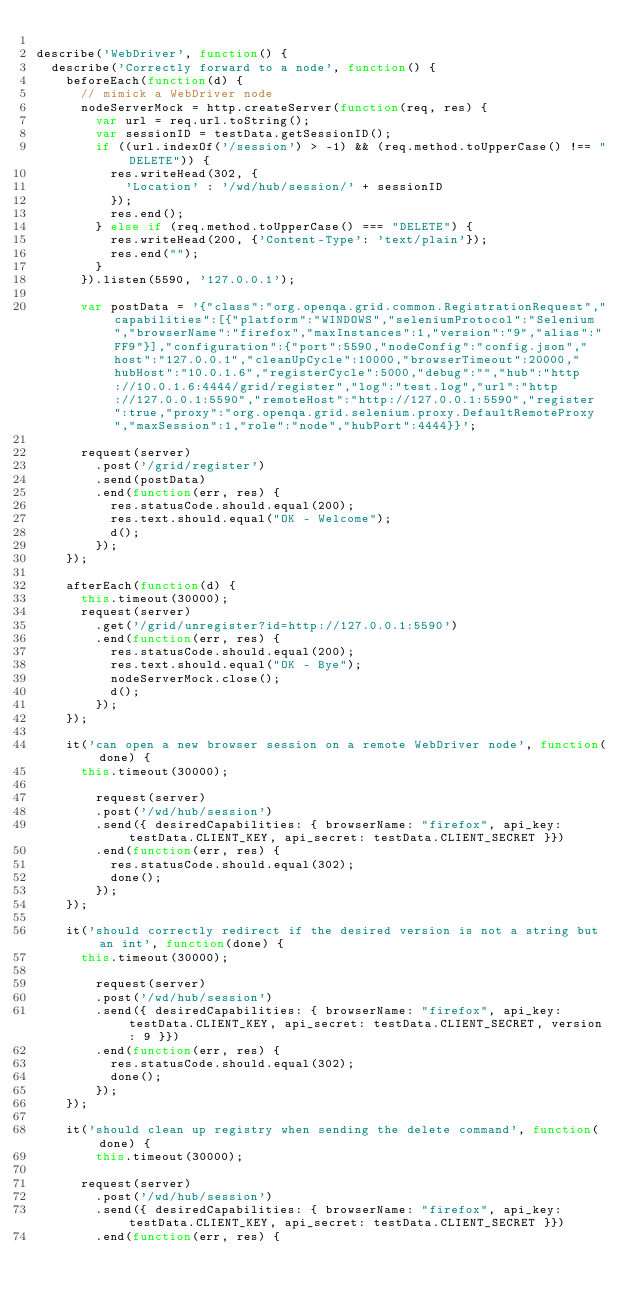<code> <loc_0><loc_0><loc_500><loc_500><_JavaScript_>
describe('WebDriver', function() {
	describe('Correctly forward to a node', function() {
		beforeEach(function(d) {
			// mimick a WebDriver node
			nodeServerMock = http.createServer(function(req, res) {
			  var url = req.url.toString();
			  var sessionID = testData.getSessionID();
			  if ((url.indexOf('/session') > -1) && (req.method.toUpperCase() !== "DELETE")) {
			  	res.writeHead(302, {
			  		'Location' : '/wd/hub/session/' + sessionID
			  	});
			  	res.end();
			  } else if (req.method.toUpperCase() === "DELETE") {
			  	res.writeHead(200, {'Content-Type': 'text/plain'});
	  			res.end("");
			  }
			}).listen(5590, '127.0.0.1');

			var postData = '{"class":"org.openqa.grid.common.RegistrationRequest","capabilities":[{"platform":"WINDOWS","seleniumProtocol":"Selenium","browserName":"firefox","maxInstances":1,"version":"9","alias":"FF9"}],"configuration":{"port":5590,"nodeConfig":"config.json","host":"127.0.0.1","cleanUpCycle":10000,"browserTimeout":20000,"hubHost":"10.0.1.6","registerCycle":5000,"debug":"","hub":"http://10.0.1.6:4444/grid/register","log":"test.log","url":"http://127.0.0.1:5590","remoteHost":"http://127.0.0.1:5590","register":true,"proxy":"org.openqa.grid.selenium.proxy.DefaultRemoteProxy","maxSession":1,"role":"node","hubPort":4444}}';

			request(server)
				.post('/grid/register')
				.send(postData)
				.end(function(err, res) {
					res.statusCode.should.equal(200);
					res.text.should.equal("OK - Welcome");
					d();
				});
		});

		afterEach(function(d) {
			this.timeout(30000);
			request(server)
				.get('/grid/unregister?id=http://127.0.0.1:5590')
				.end(function(err, res) {
					res.statusCode.should.equal(200);
					res.text.should.equal("OK - Bye");
					nodeServerMock.close();
					d();
				});
		});

		it('can open a new browser session on a remote WebDriver node', function(done) {
			this.timeout(30000);

		  	request(server)
				.post('/wd/hub/session')
				.send({ desiredCapabilities: { browserName: "firefox", api_key: testData.CLIENT_KEY, api_secret: testData.CLIENT_SECRET }})
				.end(function(err, res) {
					res.statusCode.should.equal(302);
					done();
				});
		});

		it('should correctly redirect if the desired version is not a string but an int', function(done) {
			this.timeout(30000);

		  	request(server)
				.post('/wd/hub/session')
				.send({ desiredCapabilities: { browserName: "firefox", api_key: testData.CLIENT_KEY, api_secret: testData.CLIENT_SECRET, version: 9 }})
				.end(function(err, res) {
					res.statusCode.should.equal(302);
					done();
				});
		});

		it('should clean up registry when sending the delete command', function(done) {
		  	this.timeout(30000);
			
			request(server)
				.post('/wd/hub/session')
				.send({ desiredCapabilities: { browserName: "firefox", api_key: testData.CLIENT_KEY, api_secret: testData.CLIENT_SECRET }})
				.end(function(err, res) {</code> 